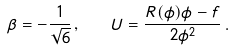<formula> <loc_0><loc_0><loc_500><loc_500>\beta = - \frac { 1 } { \sqrt { 6 } } \, , \quad U = \frac { R ( \phi ) \phi - f } { 2 \phi ^ { 2 } } \, .</formula> 